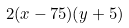Convert formula to latex. <formula><loc_0><loc_0><loc_500><loc_500>2 ( x - 7 5 ) ( y + 5 )</formula> 